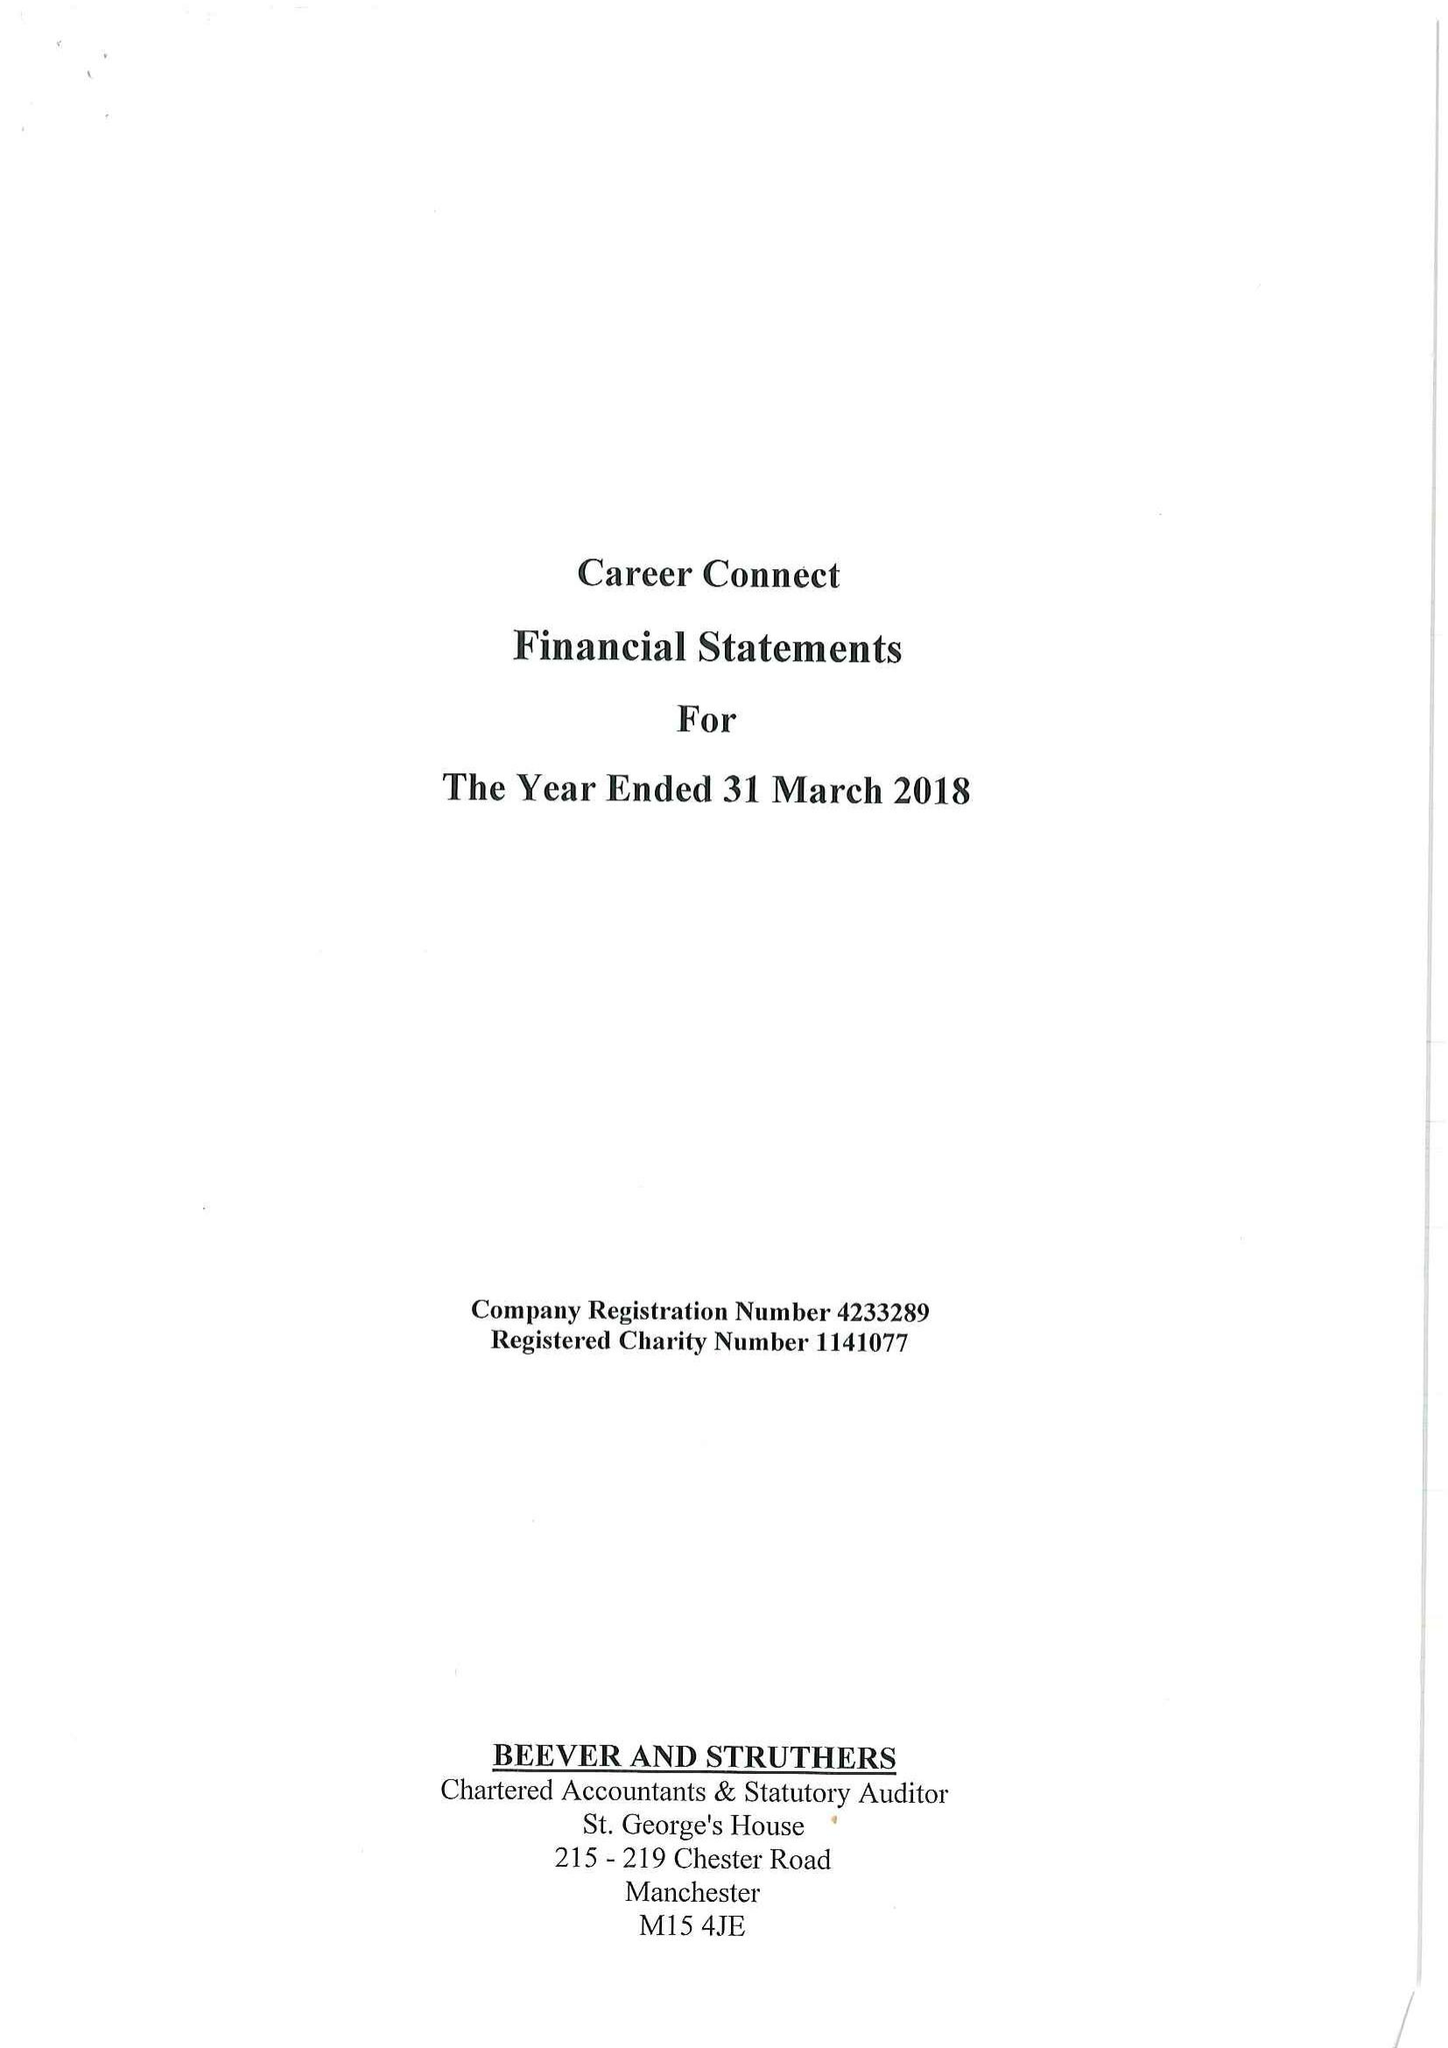What is the value for the report_date?
Answer the question using a single word or phrase. 2018-03-31 